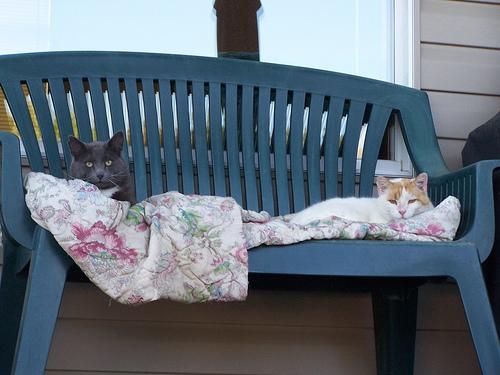What material is the bench made out of?
Write a very short answer. Plastic. What color cat is on the left?
Short answer required. Gray. Are these kitties sleeping?
Answer briefly. No. 